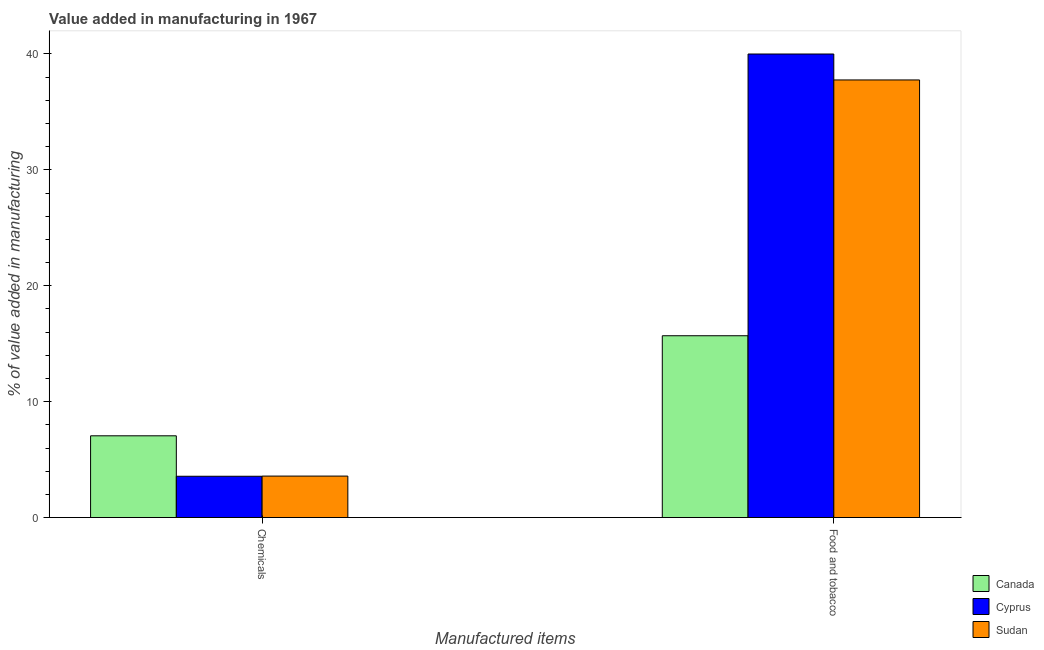How many different coloured bars are there?
Give a very brief answer. 3. Are the number of bars on each tick of the X-axis equal?
Your answer should be compact. Yes. How many bars are there on the 2nd tick from the left?
Offer a very short reply. 3. What is the label of the 2nd group of bars from the left?
Provide a succinct answer. Food and tobacco. What is the value added by  manufacturing chemicals in Sudan?
Provide a succinct answer. 3.58. Across all countries, what is the maximum value added by manufacturing food and tobacco?
Offer a terse response. 39.99. Across all countries, what is the minimum value added by  manufacturing chemicals?
Ensure brevity in your answer.  3.56. In which country was the value added by manufacturing food and tobacco maximum?
Keep it short and to the point. Cyprus. In which country was the value added by  manufacturing chemicals minimum?
Provide a short and direct response. Cyprus. What is the total value added by  manufacturing chemicals in the graph?
Offer a terse response. 14.19. What is the difference between the value added by  manufacturing chemicals in Canada and that in Cyprus?
Give a very brief answer. 3.49. What is the difference between the value added by manufacturing food and tobacco in Cyprus and the value added by  manufacturing chemicals in Canada?
Offer a very short reply. 32.94. What is the average value added by  manufacturing chemicals per country?
Provide a short and direct response. 4.73. What is the difference between the value added by manufacturing food and tobacco and value added by  manufacturing chemicals in Canada?
Provide a succinct answer. 8.63. What is the ratio of the value added by  manufacturing chemicals in Canada to that in Cyprus?
Offer a terse response. 1.98. In how many countries, is the value added by  manufacturing chemicals greater than the average value added by  manufacturing chemicals taken over all countries?
Your answer should be very brief. 1. What does the 1st bar from the left in Chemicals represents?
Keep it short and to the point. Canada. What does the 1st bar from the right in Chemicals represents?
Make the answer very short. Sudan. How many bars are there?
Offer a terse response. 6. Are the values on the major ticks of Y-axis written in scientific E-notation?
Provide a short and direct response. No. Does the graph contain grids?
Give a very brief answer. No. How many legend labels are there?
Give a very brief answer. 3. How are the legend labels stacked?
Keep it short and to the point. Vertical. What is the title of the graph?
Provide a short and direct response. Value added in manufacturing in 1967. What is the label or title of the X-axis?
Keep it short and to the point. Manufactured items. What is the label or title of the Y-axis?
Ensure brevity in your answer.  % of value added in manufacturing. What is the % of value added in manufacturing in Canada in Chemicals?
Make the answer very short. 7.05. What is the % of value added in manufacturing of Cyprus in Chemicals?
Provide a short and direct response. 3.56. What is the % of value added in manufacturing in Sudan in Chemicals?
Keep it short and to the point. 3.58. What is the % of value added in manufacturing in Canada in Food and tobacco?
Your answer should be compact. 15.69. What is the % of value added in manufacturing of Cyprus in Food and tobacco?
Offer a very short reply. 39.99. What is the % of value added in manufacturing in Sudan in Food and tobacco?
Your answer should be compact. 37.75. Across all Manufactured items, what is the maximum % of value added in manufacturing in Canada?
Your response must be concise. 15.69. Across all Manufactured items, what is the maximum % of value added in manufacturing of Cyprus?
Your answer should be compact. 39.99. Across all Manufactured items, what is the maximum % of value added in manufacturing of Sudan?
Ensure brevity in your answer.  37.75. Across all Manufactured items, what is the minimum % of value added in manufacturing in Canada?
Your response must be concise. 7.05. Across all Manufactured items, what is the minimum % of value added in manufacturing of Cyprus?
Your answer should be very brief. 3.56. Across all Manufactured items, what is the minimum % of value added in manufacturing in Sudan?
Ensure brevity in your answer.  3.58. What is the total % of value added in manufacturing of Canada in the graph?
Offer a terse response. 22.74. What is the total % of value added in manufacturing in Cyprus in the graph?
Offer a terse response. 43.55. What is the total % of value added in manufacturing of Sudan in the graph?
Make the answer very short. 41.33. What is the difference between the % of value added in manufacturing of Canada in Chemicals and that in Food and tobacco?
Your answer should be compact. -8.63. What is the difference between the % of value added in manufacturing of Cyprus in Chemicals and that in Food and tobacco?
Provide a succinct answer. -36.43. What is the difference between the % of value added in manufacturing in Sudan in Chemicals and that in Food and tobacco?
Your answer should be very brief. -34.18. What is the difference between the % of value added in manufacturing in Canada in Chemicals and the % of value added in manufacturing in Cyprus in Food and tobacco?
Provide a succinct answer. -32.94. What is the difference between the % of value added in manufacturing in Canada in Chemicals and the % of value added in manufacturing in Sudan in Food and tobacco?
Your answer should be compact. -30.7. What is the difference between the % of value added in manufacturing in Cyprus in Chemicals and the % of value added in manufacturing in Sudan in Food and tobacco?
Provide a succinct answer. -34.19. What is the average % of value added in manufacturing in Canada per Manufactured items?
Provide a succinct answer. 11.37. What is the average % of value added in manufacturing of Cyprus per Manufactured items?
Keep it short and to the point. 21.78. What is the average % of value added in manufacturing of Sudan per Manufactured items?
Your response must be concise. 20.67. What is the difference between the % of value added in manufacturing of Canada and % of value added in manufacturing of Cyprus in Chemicals?
Give a very brief answer. 3.49. What is the difference between the % of value added in manufacturing of Canada and % of value added in manufacturing of Sudan in Chemicals?
Your answer should be compact. 3.48. What is the difference between the % of value added in manufacturing of Cyprus and % of value added in manufacturing of Sudan in Chemicals?
Make the answer very short. -0.01. What is the difference between the % of value added in manufacturing of Canada and % of value added in manufacturing of Cyprus in Food and tobacco?
Make the answer very short. -24.31. What is the difference between the % of value added in manufacturing of Canada and % of value added in manufacturing of Sudan in Food and tobacco?
Offer a terse response. -22.07. What is the difference between the % of value added in manufacturing in Cyprus and % of value added in manufacturing in Sudan in Food and tobacco?
Provide a succinct answer. 2.24. What is the ratio of the % of value added in manufacturing in Canada in Chemicals to that in Food and tobacco?
Keep it short and to the point. 0.45. What is the ratio of the % of value added in manufacturing of Cyprus in Chemicals to that in Food and tobacco?
Offer a very short reply. 0.09. What is the ratio of the % of value added in manufacturing in Sudan in Chemicals to that in Food and tobacco?
Ensure brevity in your answer.  0.09. What is the difference between the highest and the second highest % of value added in manufacturing in Canada?
Offer a terse response. 8.63. What is the difference between the highest and the second highest % of value added in manufacturing in Cyprus?
Your answer should be very brief. 36.43. What is the difference between the highest and the second highest % of value added in manufacturing of Sudan?
Offer a terse response. 34.18. What is the difference between the highest and the lowest % of value added in manufacturing in Canada?
Provide a short and direct response. 8.63. What is the difference between the highest and the lowest % of value added in manufacturing in Cyprus?
Make the answer very short. 36.43. What is the difference between the highest and the lowest % of value added in manufacturing in Sudan?
Make the answer very short. 34.18. 